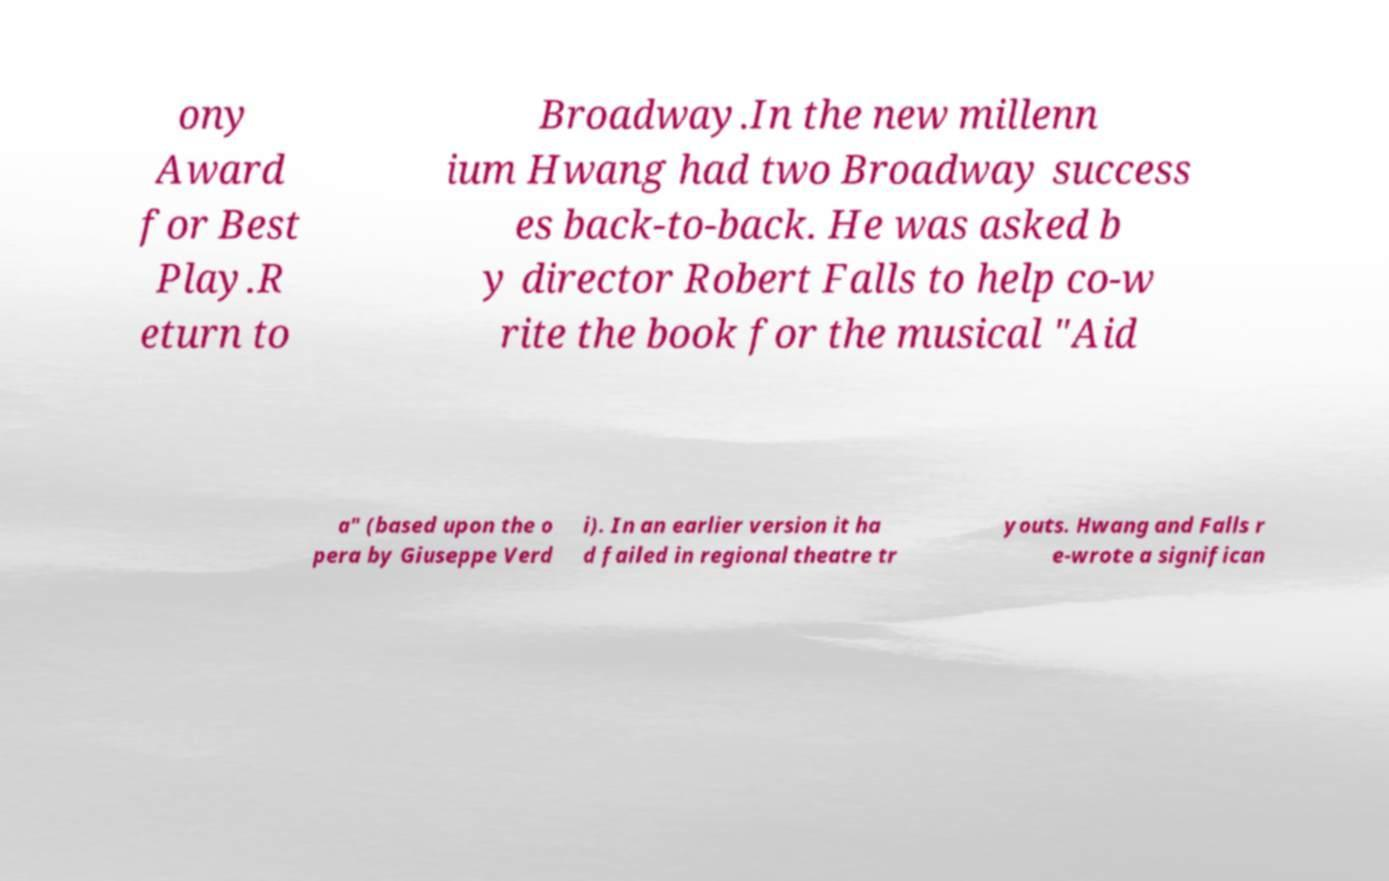Can you read and provide the text displayed in the image?This photo seems to have some interesting text. Can you extract and type it out for me? ony Award for Best Play.R eturn to Broadway.In the new millenn ium Hwang had two Broadway success es back-to-back. He was asked b y director Robert Falls to help co-w rite the book for the musical "Aid a" (based upon the o pera by Giuseppe Verd i). In an earlier version it ha d failed in regional theatre tr youts. Hwang and Falls r e-wrote a significan 